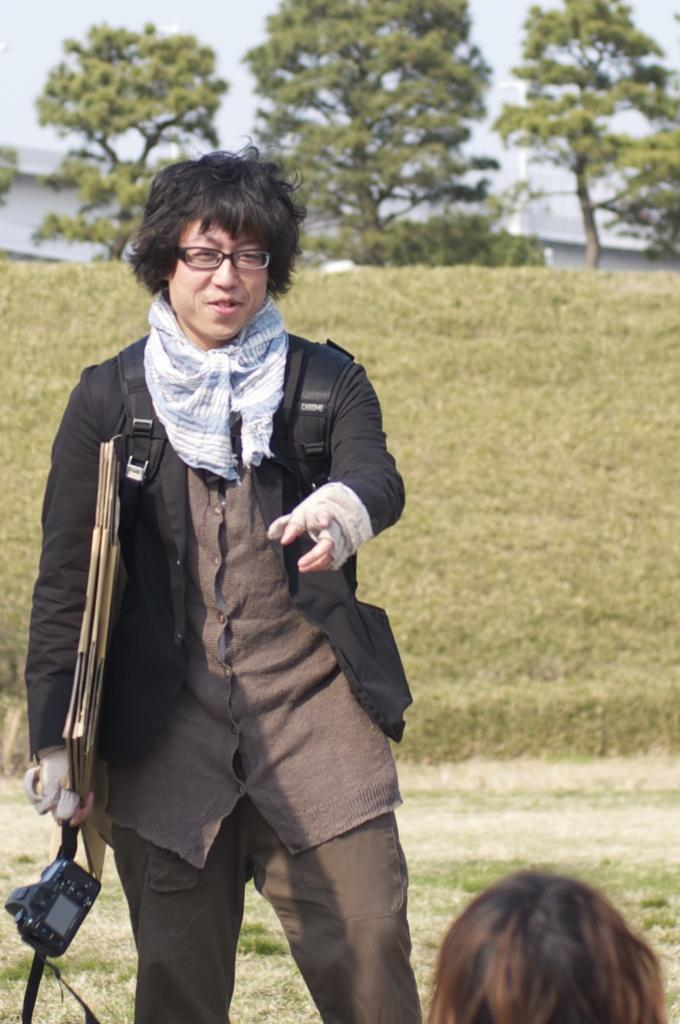What is the position of the person in the image? The person is standing at the left side of the image. What can be observed about the person's attire? The person is wearing clothes and spectacles. What is the person holding in their hands? The person is holding a device in their hands. What type of natural environment is visible in the image? There is grass, trees, and the sky visible in the image. What advice did the person's grandmother give them about their latest discovery in the image? There is no mention of a grandmother or any discovery in the image, so it is not possible to answer this question. 